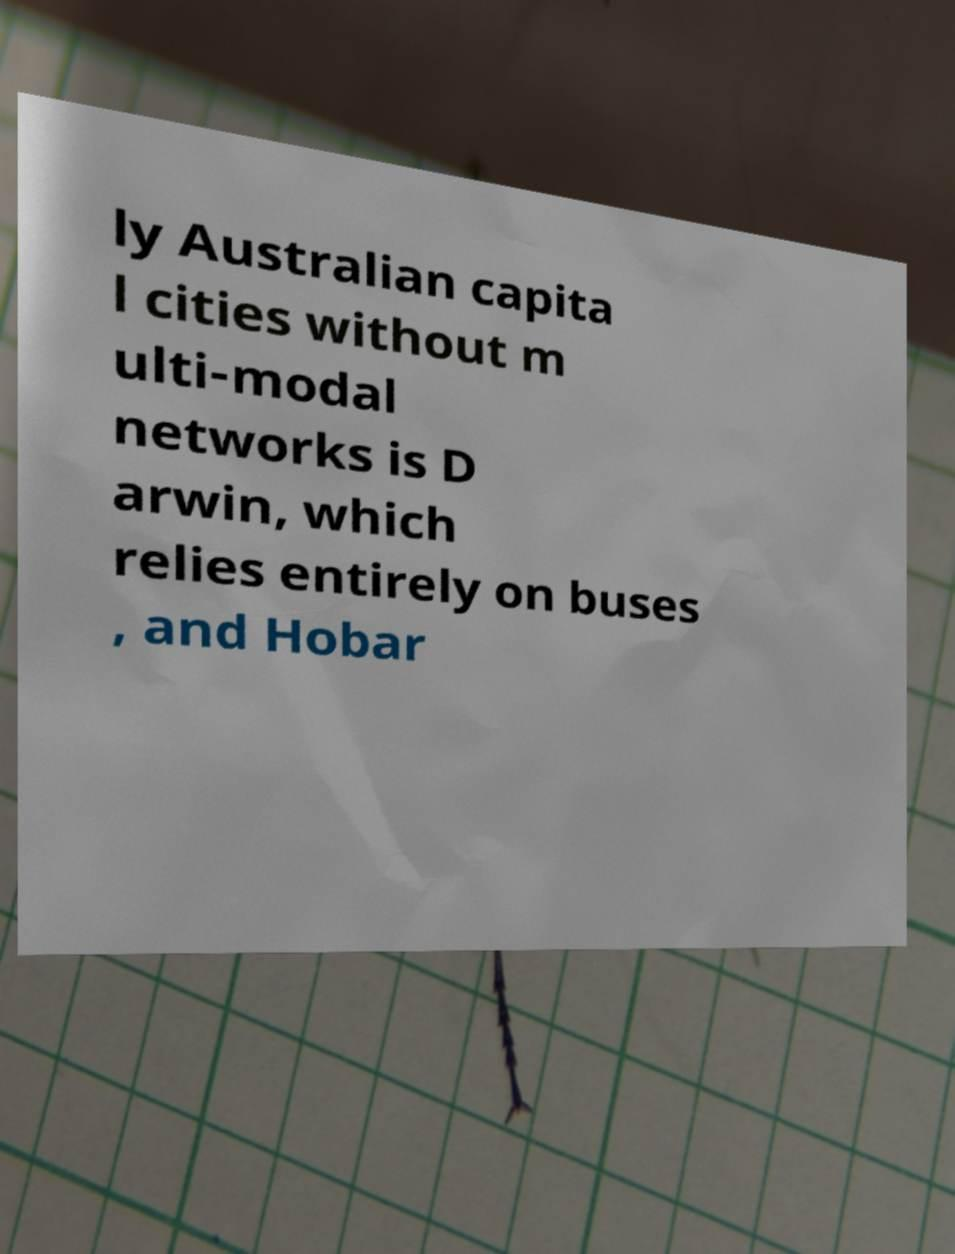There's text embedded in this image that I need extracted. Can you transcribe it verbatim? ly Australian capita l cities without m ulti-modal networks is D arwin, which relies entirely on buses , and Hobar 